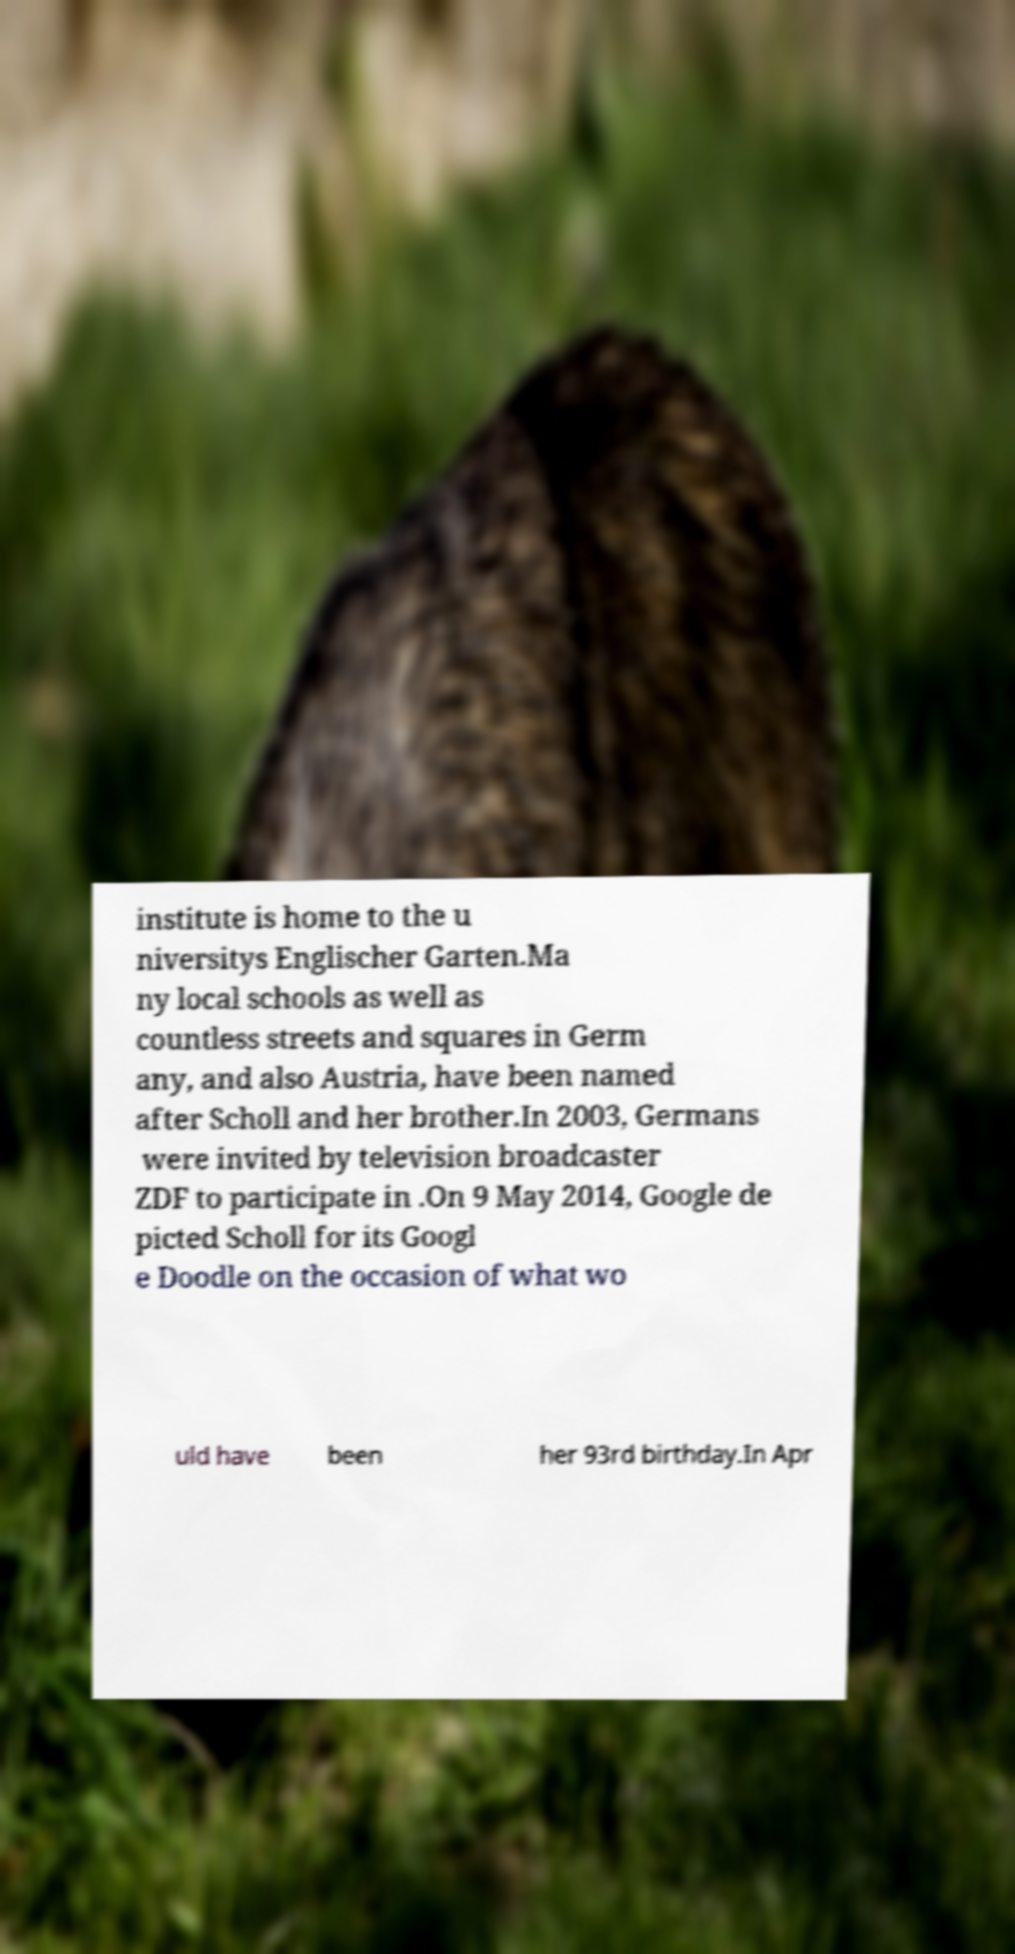What messages or text are displayed in this image? I need them in a readable, typed format. institute is home to the u niversitys Englischer Garten.Ma ny local schools as well as countless streets and squares in Germ any, and also Austria, have been named after Scholl and her brother.In 2003, Germans were invited by television broadcaster ZDF to participate in .On 9 May 2014, Google de picted Scholl for its Googl e Doodle on the occasion of what wo uld have been her 93rd birthday.In Apr 